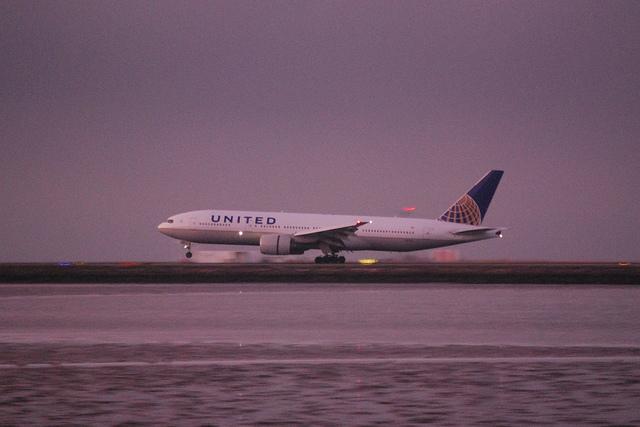What word is on the plane?
Answer briefly. United. Does this plane have a propeller?
Short answer required. No. What country does this plane hail from?
Concise answer only. Us. Did the plane just take off or is it landing?
Short answer required. Take off. 